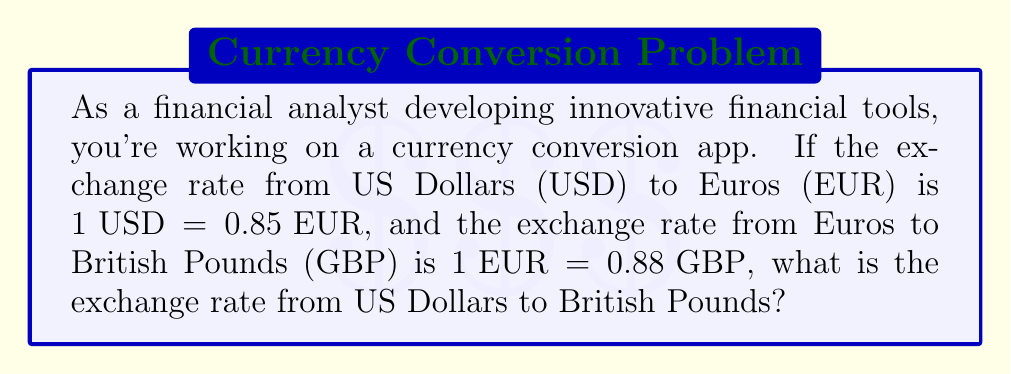Could you help me with this problem? To solve this problem, we need to use the concept of cross-multiplication with exchange rates. Let's break it down step-by-step:

1. We have two exchange rates:
   $1 USD = 0.85 EUR$
   $1 EUR = 0.88 GBP$

2. We want to find how many GBP we can get for 1 USD. We can do this by combining these two rates.

3. First, let's consider how many EUR we get for 1 USD:
   $1 USD = 0.85 EUR$

4. Now, we need to convert this 0.85 EUR to GBP. We can use the second exchange rate:
   $1 EUR = 0.88 GBP$

5. To find out how many GBP 0.85 EUR is equal to, we can set up a proportion:
   $$\frac{1 EUR}{0.88 GBP} = \frac{0.85 EUR}{x GBP}$$

6. Cross-multiply to solve for x:
   $1 * x = 0.85 * 0.88$
   $x = 0.85 * 0.88 = 0.748$

7. Therefore, 0.85 EUR = 0.748 GBP

8. Since 0.85 EUR is equivalent to 1 USD (from step 3), we can conclude that:
   $1 USD = 0.748 GBP$

This gives us the direct exchange rate from USD to GBP.
Answer: $1 USD = 0.748 GBP$ 